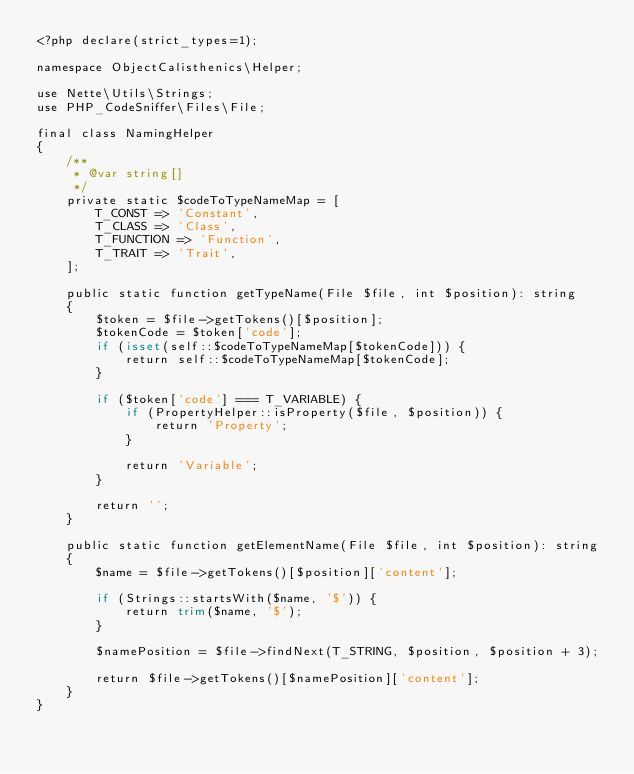Convert code to text. <code><loc_0><loc_0><loc_500><loc_500><_PHP_><?php declare(strict_types=1);

namespace ObjectCalisthenics\Helper;

use Nette\Utils\Strings;
use PHP_CodeSniffer\Files\File;

final class NamingHelper
{
    /**
     * @var string[]
     */
    private static $codeToTypeNameMap = [
        T_CONST => 'Constant',
        T_CLASS => 'Class',
        T_FUNCTION => 'Function',
        T_TRAIT => 'Trait',
    ];

    public static function getTypeName(File $file, int $position): string
    {
        $token = $file->getTokens()[$position];
        $tokenCode = $token['code'];
        if (isset(self::$codeToTypeNameMap[$tokenCode])) {
            return self::$codeToTypeNameMap[$tokenCode];
        }

        if ($token['code'] === T_VARIABLE) {
            if (PropertyHelper::isProperty($file, $position)) {
                return 'Property';
            }

            return 'Variable';
        }

        return '';
    }

    public static function getElementName(File $file, int $position): string
    {
        $name = $file->getTokens()[$position]['content'];

        if (Strings::startsWith($name, '$')) {
            return trim($name, '$');
        }

        $namePosition = $file->findNext(T_STRING, $position, $position + 3);

        return $file->getTokens()[$namePosition]['content'];
    }
}
</code> 